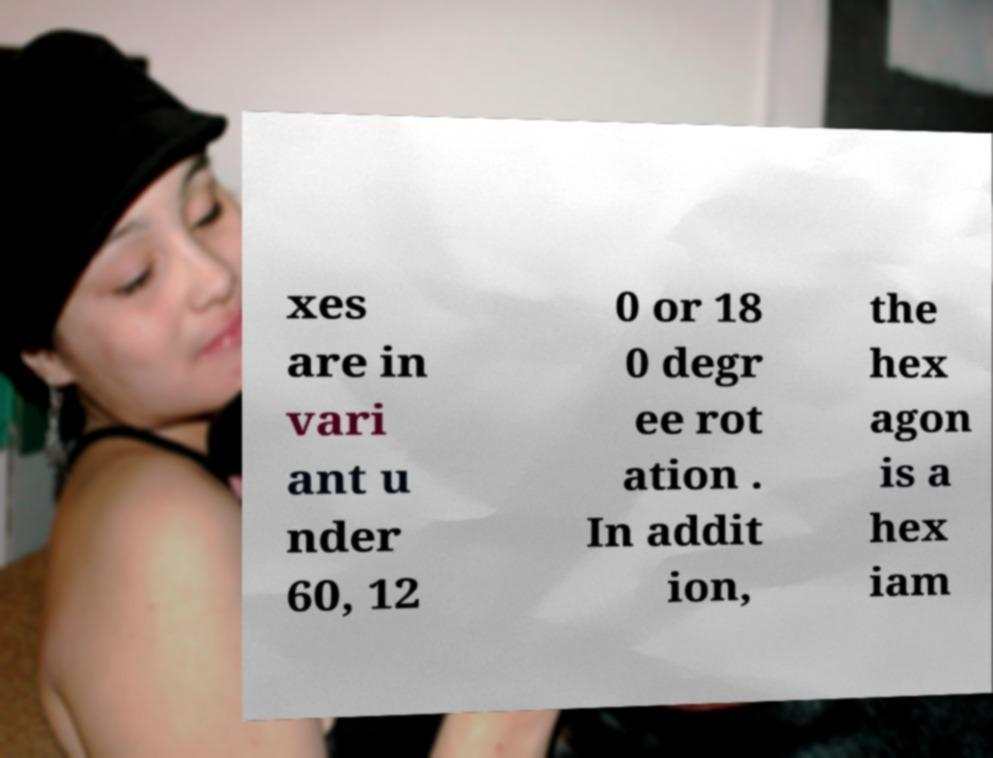I need the written content from this picture converted into text. Can you do that? xes are in vari ant u nder 60, 12 0 or 18 0 degr ee rot ation . In addit ion, the hex agon is a hex iam 